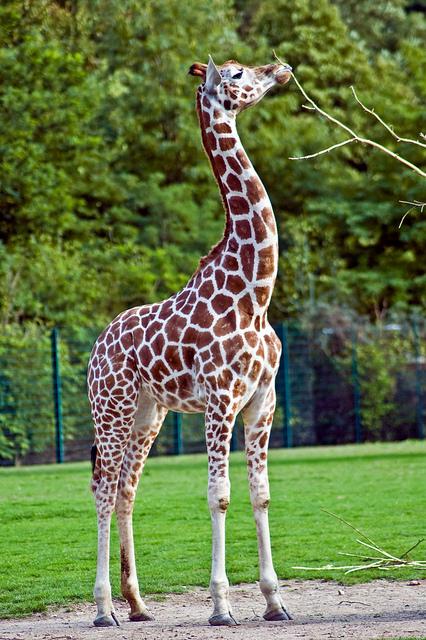What is the giraffe eating?
Concise answer only. Branch. What kind of slope do their necks form?
Quick response, please. Vertical. How many spots are on the giraffe?
Be succinct. 200. How many legs does the giraffe have?
Concise answer only. 4. Is this giraffe more than 2ft tall?
Write a very short answer. Yes. 